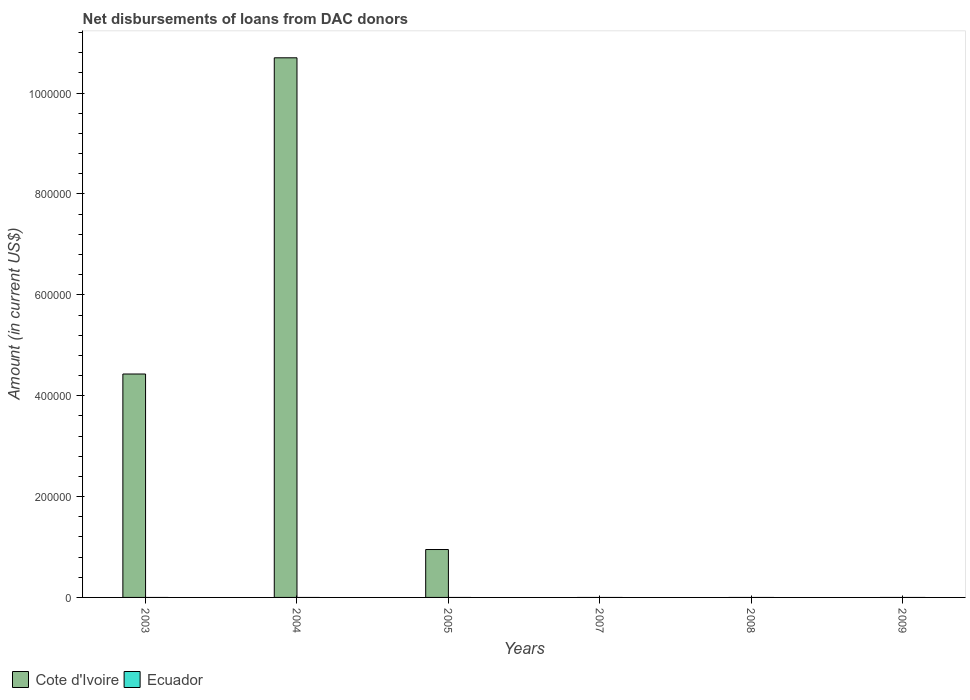Are the number of bars per tick equal to the number of legend labels?
Your answer should be compact. No. How many bars are there on the 4th tick from the left?
Provide a succinct answer. 0. What is the label of the 2nd group of bars from the left?
Make the answer very short. 2004. In how many cases, is the number of bars for a given year not equal to the number of legend labels?
Keep it short and to the point. 6. Across all years, what is the maximum amount of loans disbursed in Cote d'Ivoire?
Keep it short and to the point. 1.07e+06. Across all years, what is the minimum amount of loans disbursed in Ecuador?
Offer a terse response. 0. What is the total amount of loans disbursed in Cote d'Ivoire in the graph?
Keep it short and to the point. 1.61e+06. What is the difference between the amount of loans disbursed in Cote d'Ivoire in 2003 and that in 2004?
Keep it short and to the point. -6.27e+05. What is the difference between the amount of loans disbursed in Ecuador in 2007 and the amount of loans disbursed in Cote d'Ivoire in 2004?
Provide a short and direct response. -1.07e+06. What is the average amount of loans disbursed in Cote d'Ivoire per year?
Offer a very short reply. 2.68e+05. What is the ratio of the amount of loans disbursed in Cote d'Ivoire in 2003 to that in 2005?
Give a very brief answer. 4.66. What is the difference between the highest and the second highest amount of loans disbursed in Cote d'Ivoire?
Provide a short and direct response. 6.27e+05. What is the difference between the highest and the lowest amount of loans disbursed in Cote d'Ivoire?
Keep it short and to the point. 1.07e+06. Is the sum of the amount of loans disbursed in Cote d'Ivoire in 2003 and 2004 greater than the maximum amount of loans disbursed in Ecuador across all years?
Your response must be concise. Yes. How many bars are there?
Provide a succinct answer. 3. Are all the bars in the graph horizontal?
Ensure brevity in your answer.  No. Does the graph contain grids?
Give a very brief answer. No. Where does the legend appear in the graph?
Keep it short and to the point. Bottom left. How many legend labels are there?
Make the answer very short. 2. What is the title of the graph?
Provide a succinct answer. Net disbursements of loans from DAC donors. Does "Cote d'Ivoire" appear as one of the legend labels in the graph?
Offer a very short reply. Yes. What is the label or title of the Y-axis?
Offer a very short reply. Amount (in current US$). What is the Amount (in current US$) in Cote d'Ivoire in 2003?
Ensure brevity in your answer.  4.43e+05. What is the Amount (in current US$) in Ecuador in 2003?
Keep it short and to the point. 0. What is the Amount (in current US$) in Cote d'Ivoire in 2004?
Keep it short and to the point. 1.07e+06. What is the Amount (in current US$) in Ecuador in 2004?
Ensure brevity in your answer.  0. What is the Amount (in current US$) in Cote d'Ivoire in 2005?
Offer a very short reply. 9.50e+04. What is the Amount (in current US$) in Ecuador in 2005?
Your answer should be very brief. 0. What is the Amount (in current US$) in Cote d'Ivoire in 2008?
Keep it short and to the point. 0. What is the Amount (in current US$) in Ecuador in 2008?
Your answer should be very brief. 0. Across all years, what is the maximum Amount (in current US$) in Cote d'Ivoire?
Offer a terse response. 1.07e+06. Across all years, what is the minimum Amount (in current US$) of Cote d'Ivoire?
Keep it short and to the point. 0. What is the total Amount (in current US$) of Cote d'Ivoire in the graph?
Provide a short and direct response. 1.61e+06. What is the difference between the Amount (in current US$) of Cote d'Ivoire in 2003 and that in 2004?
Provide a succinct answer. -6.27e+05. What is the difference between the Amount (in current US$) in Cote d'Ivoire in 2003 and that in 2005?
Provide a short and direct response. 3.48e+05. What is the difference between the Amount (in current US$) in Cote d'Ivoire in 2004 and that in 2005?
Provide a succinct answer. 9.75e+05. What is the average Amount (in current US$) of Cote d'Ivoire per year?
Make the answer very short. 2.68e+05. What is the ratio of the Amount (in current US$) in Cote d'Ivoire in 2003 to that in 2004?
Offer a very short reply. 0.41. What is the ratio of the Amount (in current US$) of Cote d'Ivoire in 2003 to that in 2005?
Ensure brevity in your answer.  4.66. What is the ratio of the Amount (in current US$) in Cote d'Ivoire in 2004 to that in 2005?
Your answer should be very brief. 11.26. What is the difference between the highest and the second highest Amount (in current US$) of Cote d'Ivoire?
Offer a very short reply. 6.27e+05. What is the difference between the highest and the lowest Amount (in current US$) in Cote d'Ivoire?
Provide a succinct answer. 1.07e+06. 